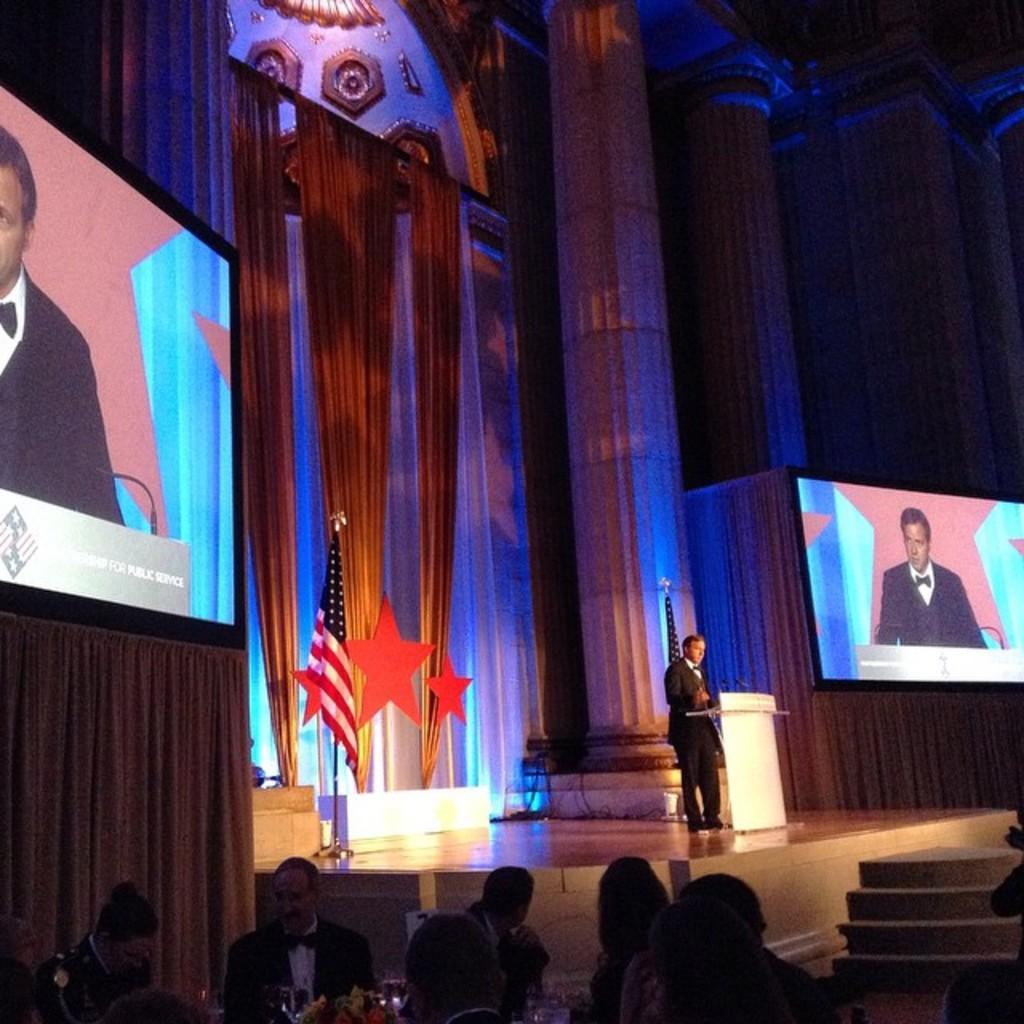Could you give a brief overview of what you see in this image? In this image, we can see curtains and pillars. There are persons at the bottom of the image. There is a screen on the left and on the right side of the image. There is flag in the middle of the image. There is a person standing in front of the podium. There are steps in the bottom right of the image. 